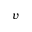Convert formula to latex. <formula><loc_0><loc_0><loc_500><loc_500>v</formula> 